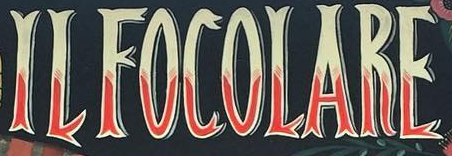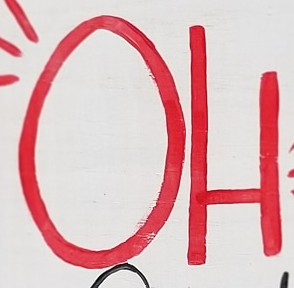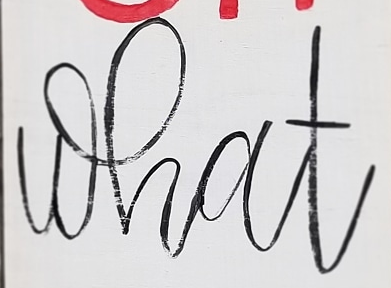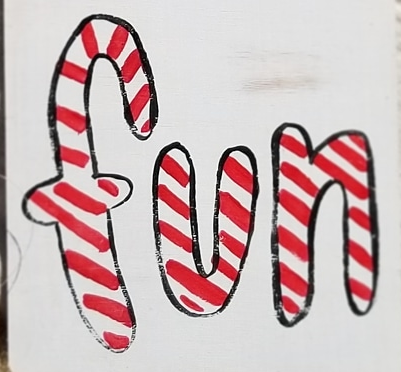Read the text from these images in sequence, separated by a semicolon. ILFOCOLARE; OH; what; fun 